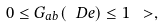Convert formula to latex. <formula><loc_0><loc_0><loc_500><loc_500>0 \leq G _ { a b } ( \ D e ) \leq 1 \ > ,</formula> 